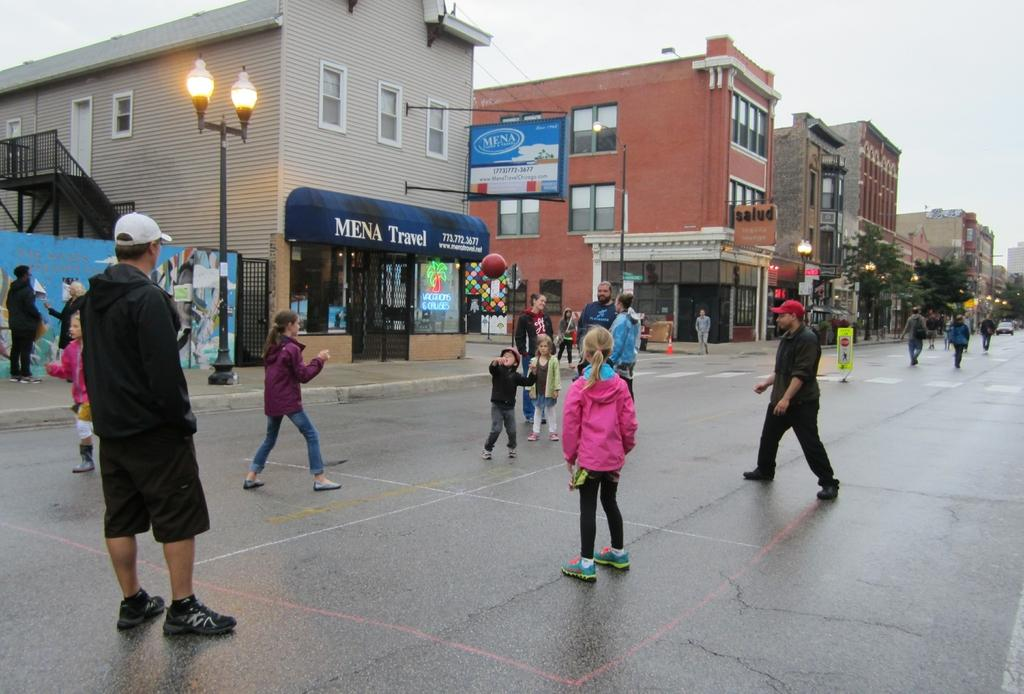How many people can be seen in the image? There are people in the image, but the exact number is not specified. What type of pathway is present in the image? There is a road in the image. What structures are present in the image? There are poles, lights, boards, a ball, windows, and buildings in the image. What is visible in the background of the image? The sky is visible in the background of the image. What type of sponge is being used to clean the windows in the image? There is no sponge present in the image, and the windows are not being cleaned. Are the brothers in the image playing with the ball together? There is no mention of brothers or playing with the ball in the image. 